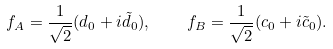<formula> <loc_0><loc_0><loc_500><loc_500>f _ { A } = \frac { 1 } { \sqrt { 2 } } ( d _ { 0 } + i \tilde { d } _ { 0 } ) , \quad f _ { B } = \frac { 1 } { \sqrt { 2 } } ( c _ { 0 } + i \tilde { c } _ { 0 } ) .</formula> 